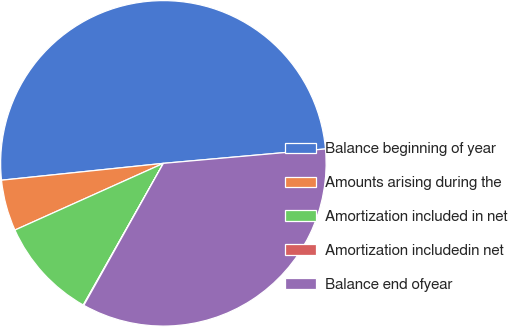Convert chart to OTSL. <chart><loc_0><loc_0><loc_500><loc_500><pie_chart><fcel>Balance beginning of year<fcel>Amounts arising during the<fcel>Amortization included in net<fcel>Amortization includedin net<fcel>Balance end ofyear<nl><fcel>50.24%<fcel>5.07%<fcel>10.09%<fcel>0.06%<fcel>34.54%<nl></chart> 